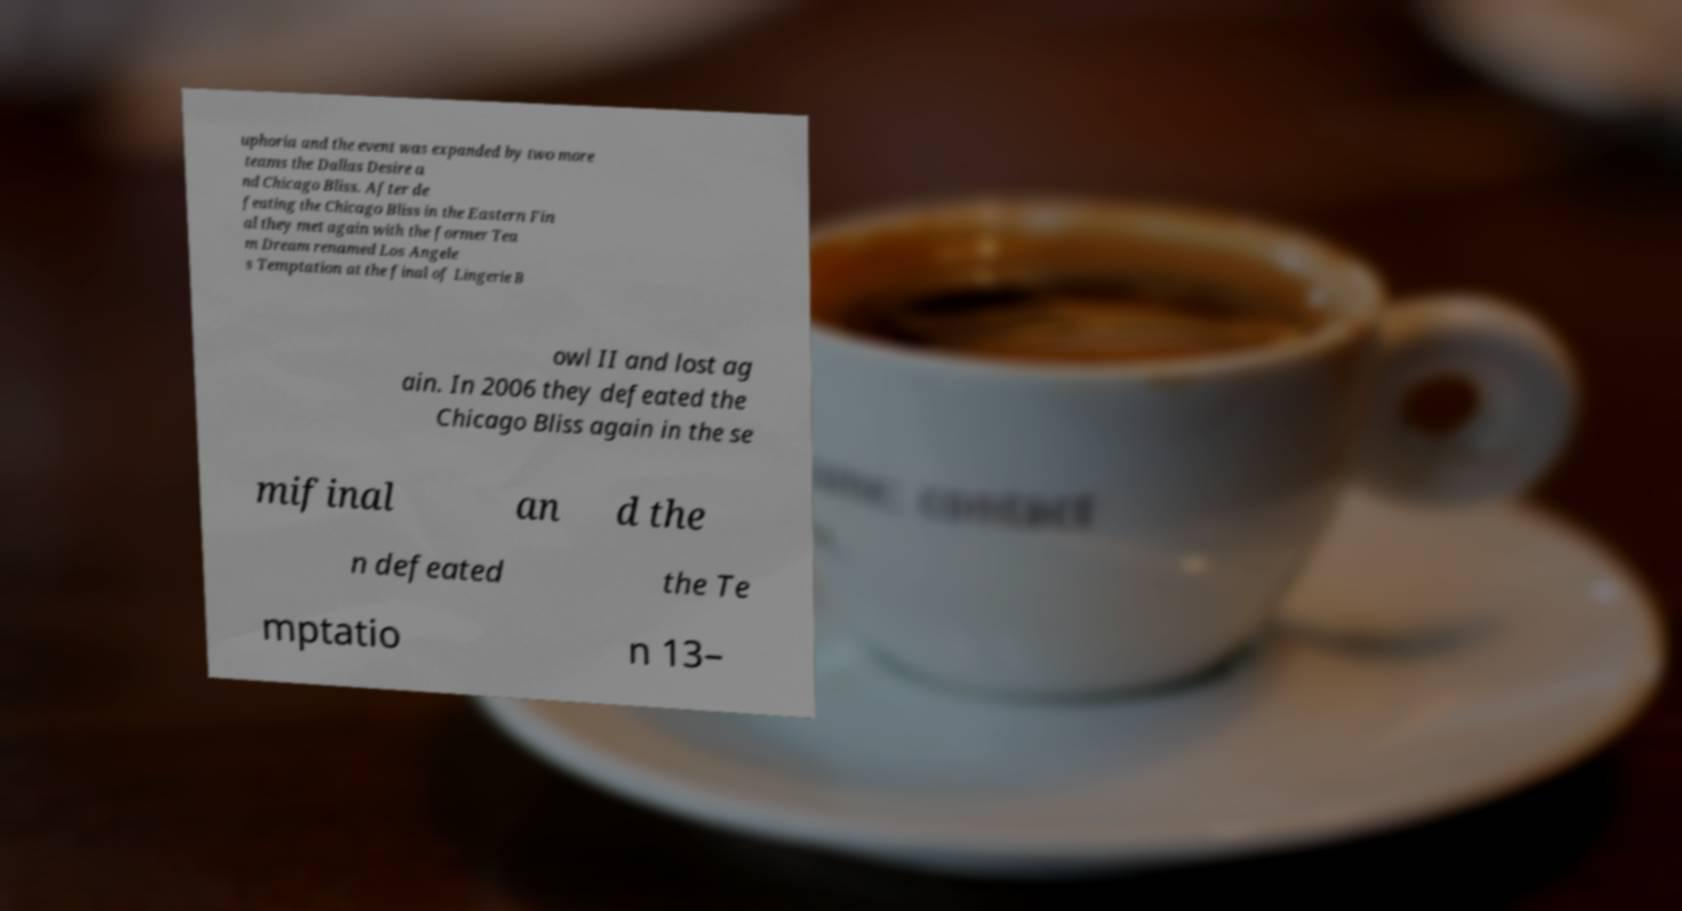Please read and relay the text visible in this image. What does it say? uphoria and the event was expanded by two more teams the Dallas Desire a nd Chicago Bliss. After de feating the Chicago Bliss in the Eastern Fin al they met again with the former Tea m Dream renamed Los Angele s Temptation at the final of Lingerie B owl II and lost ag ain. In 2006 they defeated the Chicago Bliss again in the se mifinal an d the n defeated the Te mptatio n 13– 